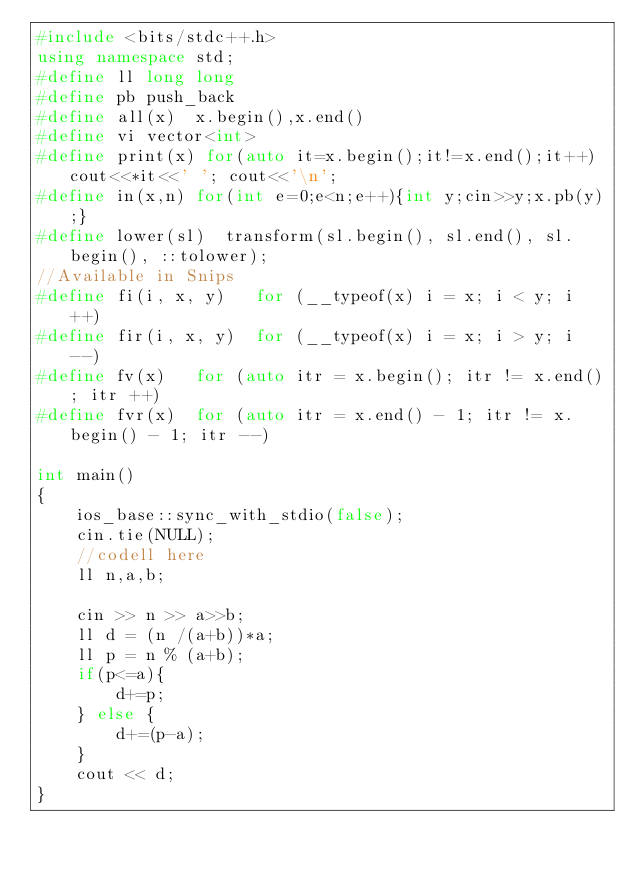Convert code to text. <code><loc_0><loc_0><loc_500><loc_500><_C++_>#include <bits/stdc++.h>
using namespace std;
#define ll long long
#define pb push_back
#define all(x)  x.begin(),x.end()
#define vi vector<int>
#define print(x) for(auto it=x.begin();it!=x.end();it++) cout<<*it<<' '; cout<<'\n';
#define in(x,n) for(int e=0;e<n;e++){int y;cin>>y;x.pb(y);}
#define lower(sl)  transform(sl.begin(), sl.end(), sl.begin(), ::tolower); 
//Available in Snips
#define fi(i, x, y)   for (__typeof(x) i = x; i < y; i ++)
#define fir(i, x, y)  for (__typeof(x) i = x; i > y; i --)
#define fv(x)   for (auto itr = x.begin(); itr != x.end(); itr ++)
#define fvr(x)  for (auto itr = x.end() - 1; itr != x.begin() - 1; itr --)
 
int main()
{
	ios_base::sync_with_stdio(false);
	cin.tie(NULL);
	//codell here
	ll n,a,b;

	cin >> n >> a>>b;
	ll d = (n /(a+b))*a;
	ll p = n % (a+b);
	if(p<=a){
		d+=p;
	} else {
		d+=(p-a);
	}
	cout << d;
}</code> 